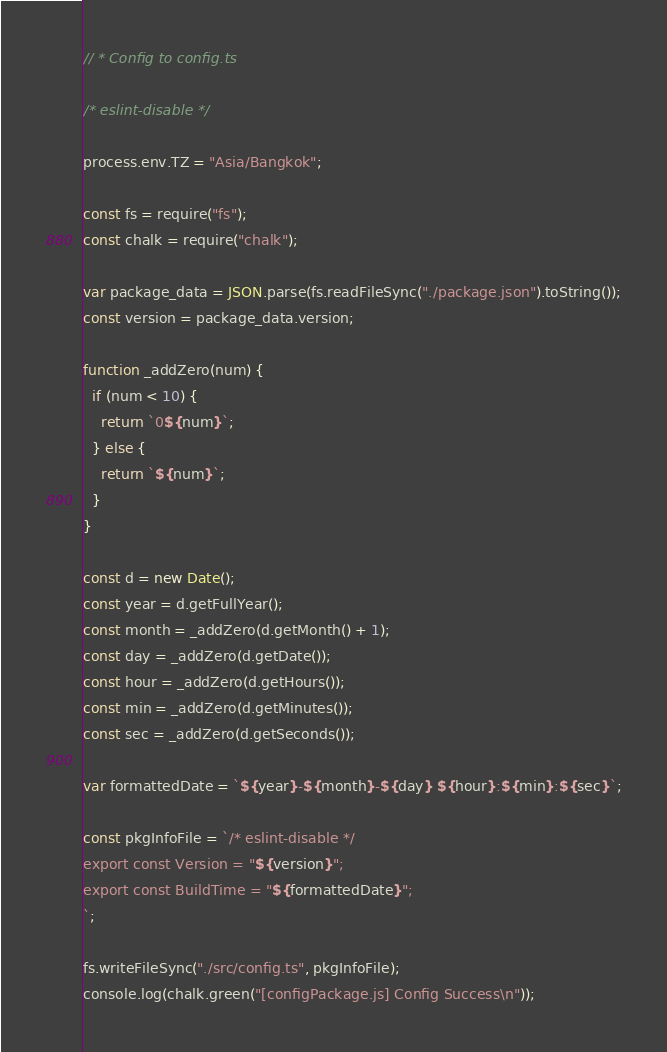<code> <loc_0><loc_0><loc_500><loc_500><_JavaScript_>// * Config to config.ts

/* eslint-disable */

process.env.TZ = "Asia/Bangkok";

const fs = require("fs");
const chalk = require("chalk");

var package_data = JSON.parse(fs.readFileSync("./package.json").toString());
const version = package_data.version;

function _addZero(num) {
  if (num < 10) {
    return `0${num}`;
  } else {
    return `${num}`;
  }
}

const d = new Date();
const year = d.getFullYear();
const month = _addZero(d.getMonth() + 1);
const day = _addZero(d.getDate());
const hour = _addZero(d.getHours());
const min = _addZero(d.getMinutes());
const sec = _addZero(d.getSeconds());

var formattedDate = `${year}-${month}-${day} ${hour}:${min}:${sec}`;

const pkgInfoFile = `/* eslint-disable */
export const Version = "${version}";
export const BuildTime = "${formattedDate}";
`;

fs.writeFileSync("./src/config.ts", pkgInfoFile);
console.log(chalk.green("[configPackage.js] Config Success\n"));
</code> 